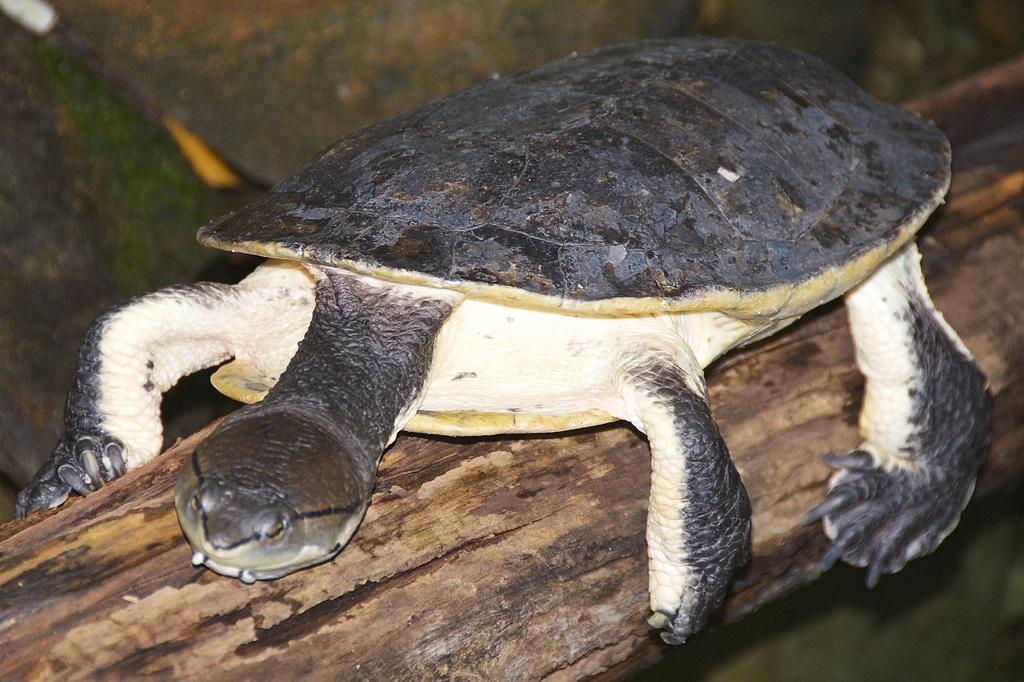In one or two sentences, can you explain what this image depicts? In this picture there is a tortoise in the center of the image, on the log and there is greenery in the background area of the image. 